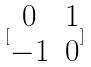<formula> <loc_0><loc_0><loc_500><loc_500>[ \begin{matrix} 0 & 1 \\ - 1 & 0 \end{matrix} ]</formula> 